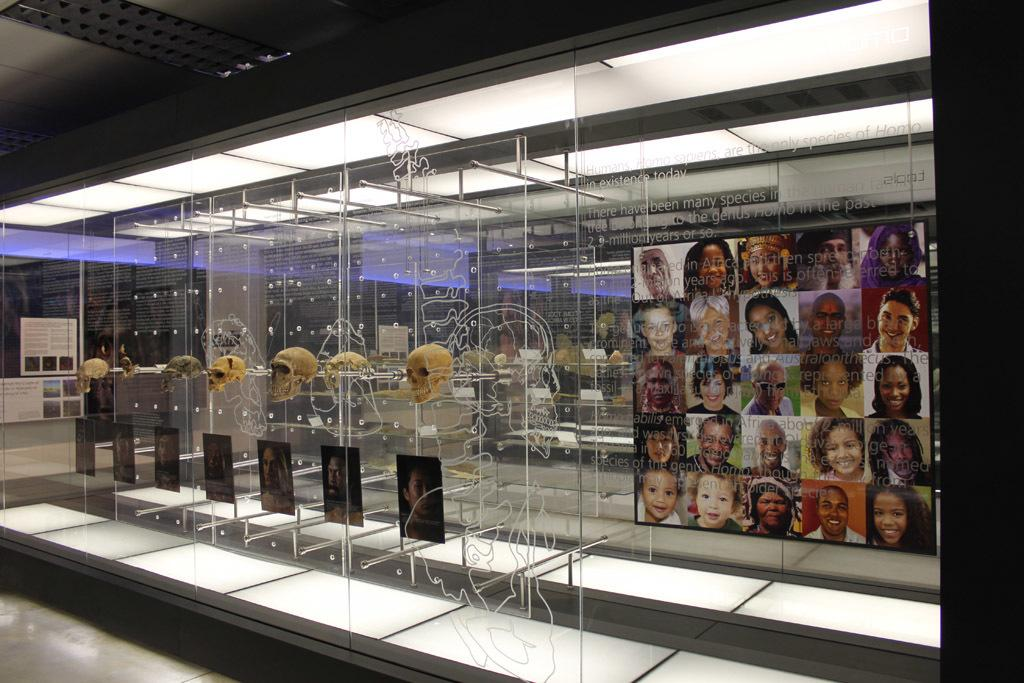What objects are on glass stands in the image? There are skulls on glass stands in the image. What is placed under the skulls? Photos of people are present under the skulls. What can be seen in the background of the image? There is a poster of pictures and boards visible in the background. What type of lighting is present in the background? Lights are present in the background. What type of metal can be seen attached to the horn in the image? There is no horn present in the image, so it is not possible to determine what type of metal might be attached to it. 